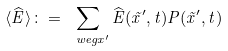<formula> <loc_0><loc_0><loc_500><loc_500>\langle \widehat { E } \rangle \colon = \sum _ { \ w e g { x } ^ { \prime } } \widehat { E } ( \vec { x } ^ { \prime } , t ) P ( \vec { x } ^ { \prime } , t )</formula> 